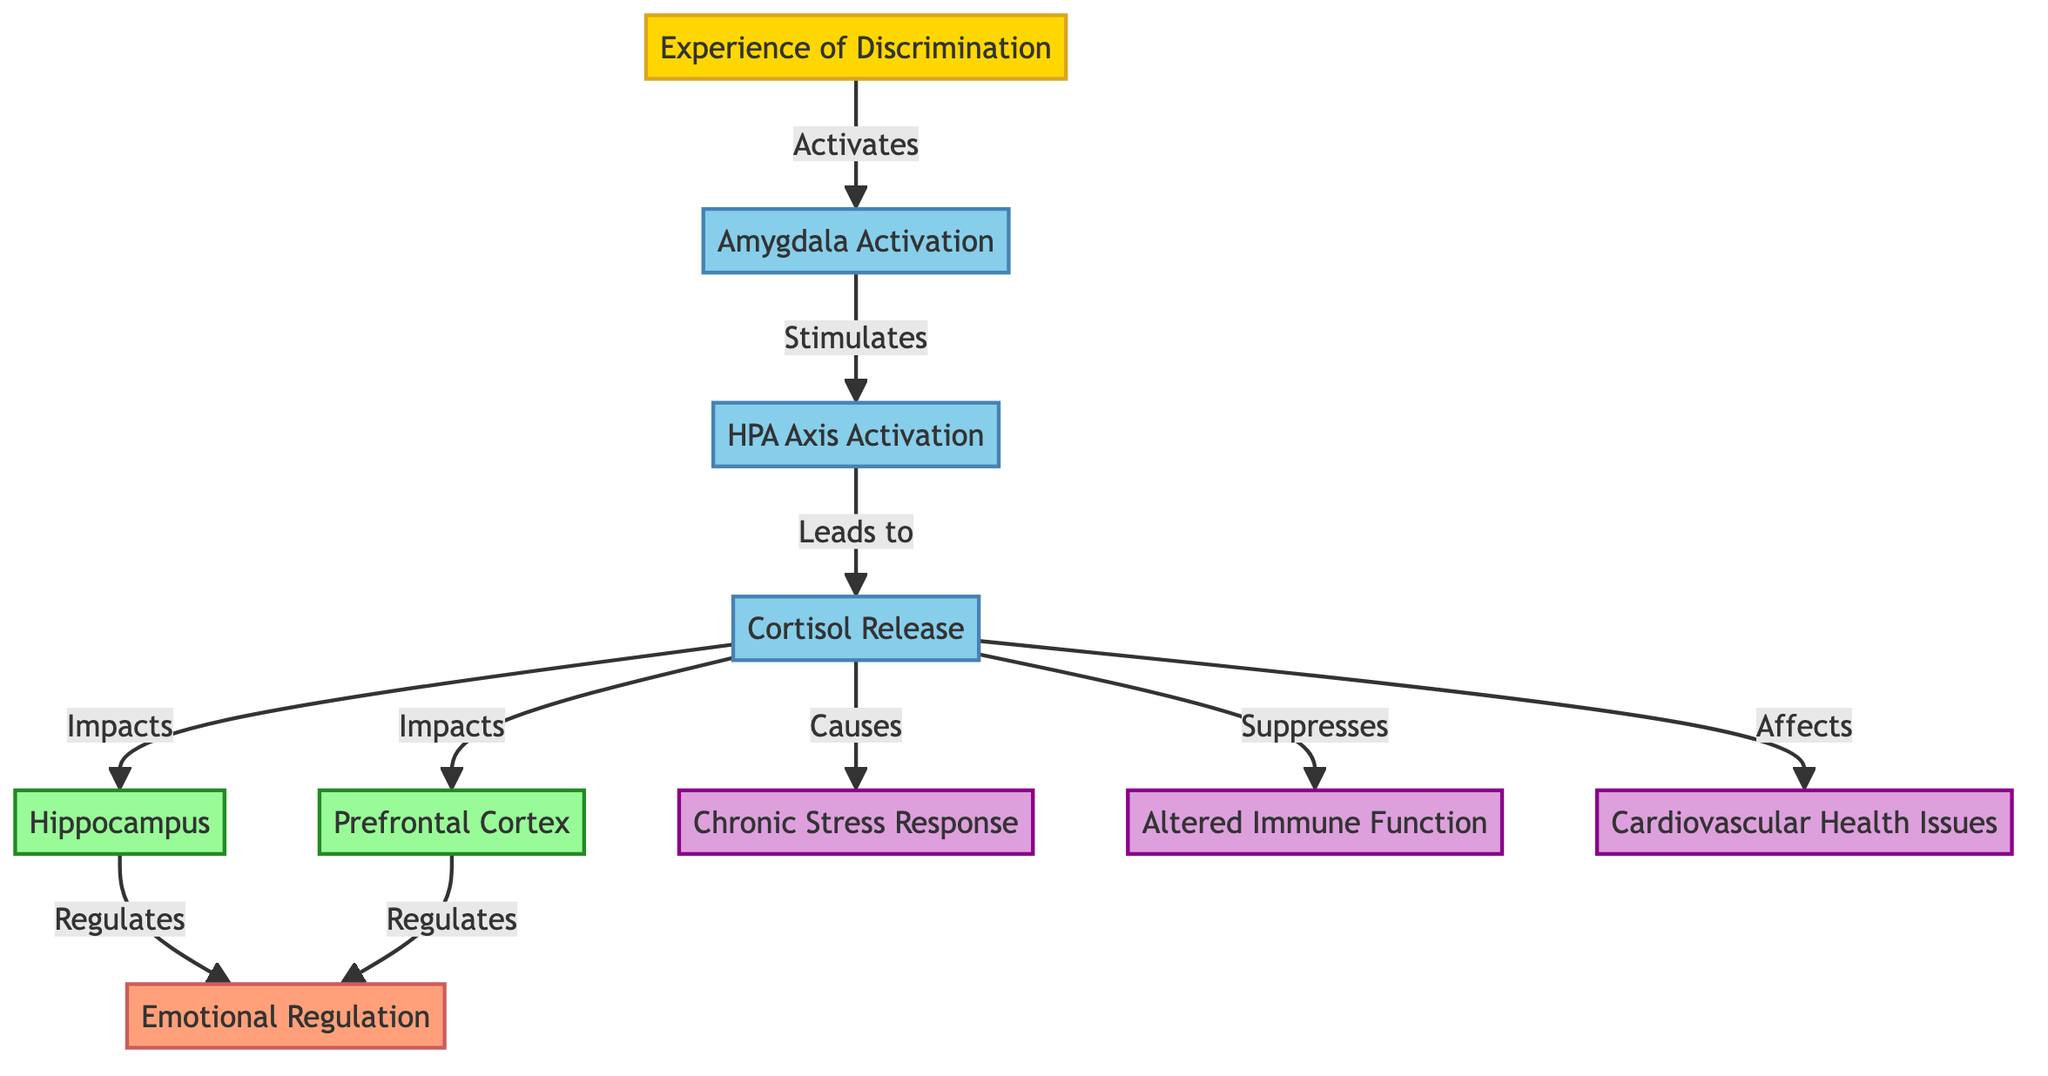What is the first event activated by experiences of discrimination? The diagram shows that "Experience of Discrimination" activates the "Amygdala". Therefore, the first event is the amygdala activation.
Answer: Amygdala Activation How many processes are directly impacted by cortisol release? The diagram indicates that "Cortisol Release" directly impacts three processes: "Hippocampus," "Prefrontal Cortex," and "Stress Response." Counting these relationships gives us three processes.
Answer: 3 What regulates emotional regulation according to the diagram? The diagram illustrates that both the "Hippocampus" and "Prefrontal Cortex" work to regulate "Emotional Regulation." Thus, both structures are responsible for this regulation.
Answer: Hippocampus and Prefrontal Cortex What effects result from cortisol release as indicated in the diagram? The flowchart reveals that cortisol release has three effects: "Chronic Stress Response," "Altered Immune Function," and "Cardiovascular Health Issues." Therefore, these are the effects caused by cortisol release.
Answer: Chronic Stress Response, Altered Immune Function, Cardiovascular Health Issues Which structure is impacted by cortisol release and contributes to emotional regulation? In the diagram, "Hippocampus" is shown to be impacted by cortisol release and additionally regulates emotional regulation. Thus, the structure that fits both criteria is the hippocampus.
Answer: Hippocampus What activation occurs after amygdala activation? According to the diagram, the "Amygdala Activation" stimulates the "HPA Axis." So, the first activation after the amygdala is the HPA axis.
Answer: HPA Axis Activation Which node shows the initial experience leading to physiological responses? The diagram begins with the "Experience of Discrimination," which regardless of subsequent processes and structures, is the initial point that leads to various physiological responses depicted in the flowchart.
Answer: Experience of Discrimination What is suppressed by cortisol release? The diagram indicates that "Cortisol Release" suppresses "Immune Function." This is a clear relationship stating what is directly hindered by cortisol.
Answer: Immune Function How does the HPA axis relate to cortisol release? The diagram shows an arrow leading from "HPA Axis Activation" to "Cortisol Release," indicating that the activation of the HPA axis leads to the release of cortisol. This establishes a direct relationship between the two elements.
Answer: HPA Axis Activation leads to Cortisol Release 